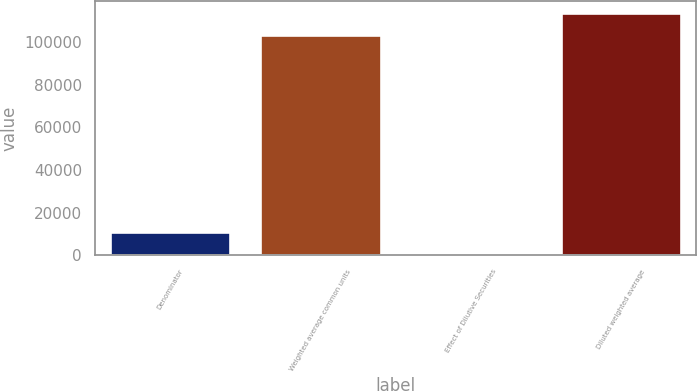Convert chart. <chart><loc_0><loc_0><loc_500><loc_500><bar_chart><fcel>Denominator<fcel>Weighted average common units<fcel>Effect of Dilutive Securities<fcel>Diluted weighted average<nl><fcel>10814.4<fcel>103244<fcel>490<fcel>113568<nl></chart> 